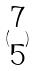<formula> <loc_0><loc_0><loc_500><loc_500>( \begin{matrix} 7 \\ 5 \end{matrix} )</formula> 